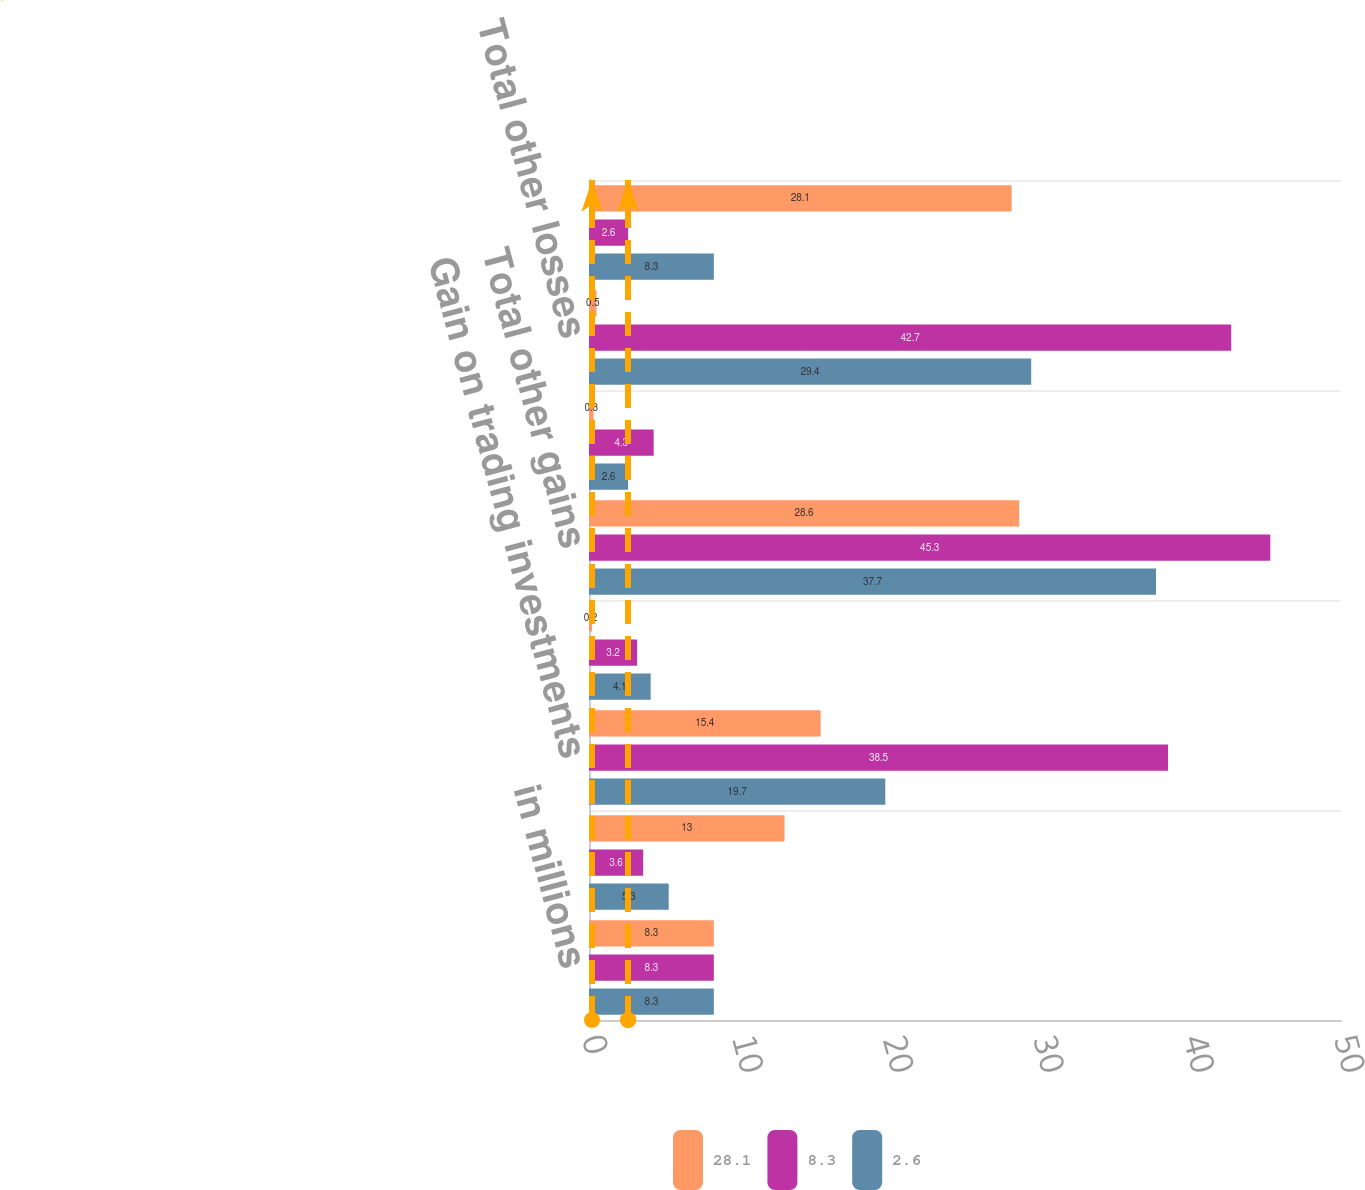<chart> <loc_0><loc_0><loc_500><loc_500><stacked_bar_chart><ecel><fcel>in millions<fcel>Gain on sale of investments<fcel>Gain on trading investments<fcel>Other realized gains<fcel>Total other gains<fcel>Other realized losses<fcel>Total other losses<fcel>Other gains and losses net<nl><fcel>28.1<fcel>8.3<fcel>13<fcel>15.4<fcel>0.2<fcel>28.6<fcel>0.3<fcel>0.5<fcel>28.1<nl><fcel>8.3<fcel>8.3<fcel>3.6<fcel>38.5<fcel>3.2<fcel>45.3<fcel>4.3<fcel>42.7<fcel>2.6<nl><fcel>2.6<fcel>8.3<fcel>5.3<fcel>19.7<fcel>4.1<fcel>37.7<fcel>2.6<fcel>29.4<fcel>8.3<nl></chart> 